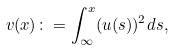Convert formula to latex. <formula><loc_0><loc_0><loc_500><loc_500>v ( x ) \colon = \int _ { \infty } ^ { x } ( u ( s ) ) ^ { 2 } d s ,</formula> 